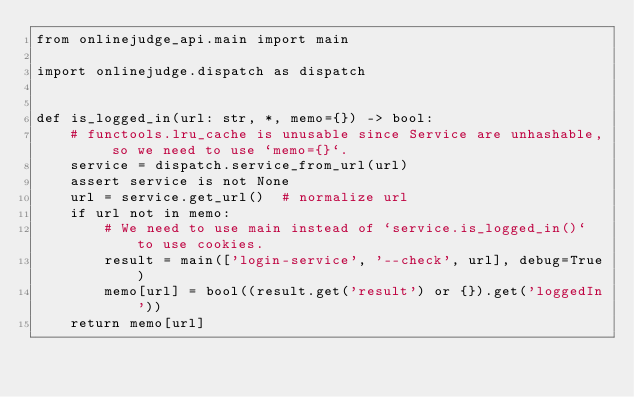<code> <loc_0><loc_0><loc_500><loc_500><_Python_>from onlinejudge_api.main import main

import onlinejudge.dispatch as dispatch


def is_logged_in(url: str, *, memo={}) -> bool:
    # functools.lru_cache is unusable since Service are unhashable, so we need to use `memo={}`.
    service = dispatch.service_from_url(url)
    assert service is not None
    url = service.get_url()  # normalize url
    if url not in memo:
        # We need to use main instead of `service.is_logged_in()` to use cookies.
        result = main(['login-service', '--check', url], debug=True)
        memo[url] = bool((result.get('result') or {}).get('loggedIn'))
    return memo[url]
</code> 